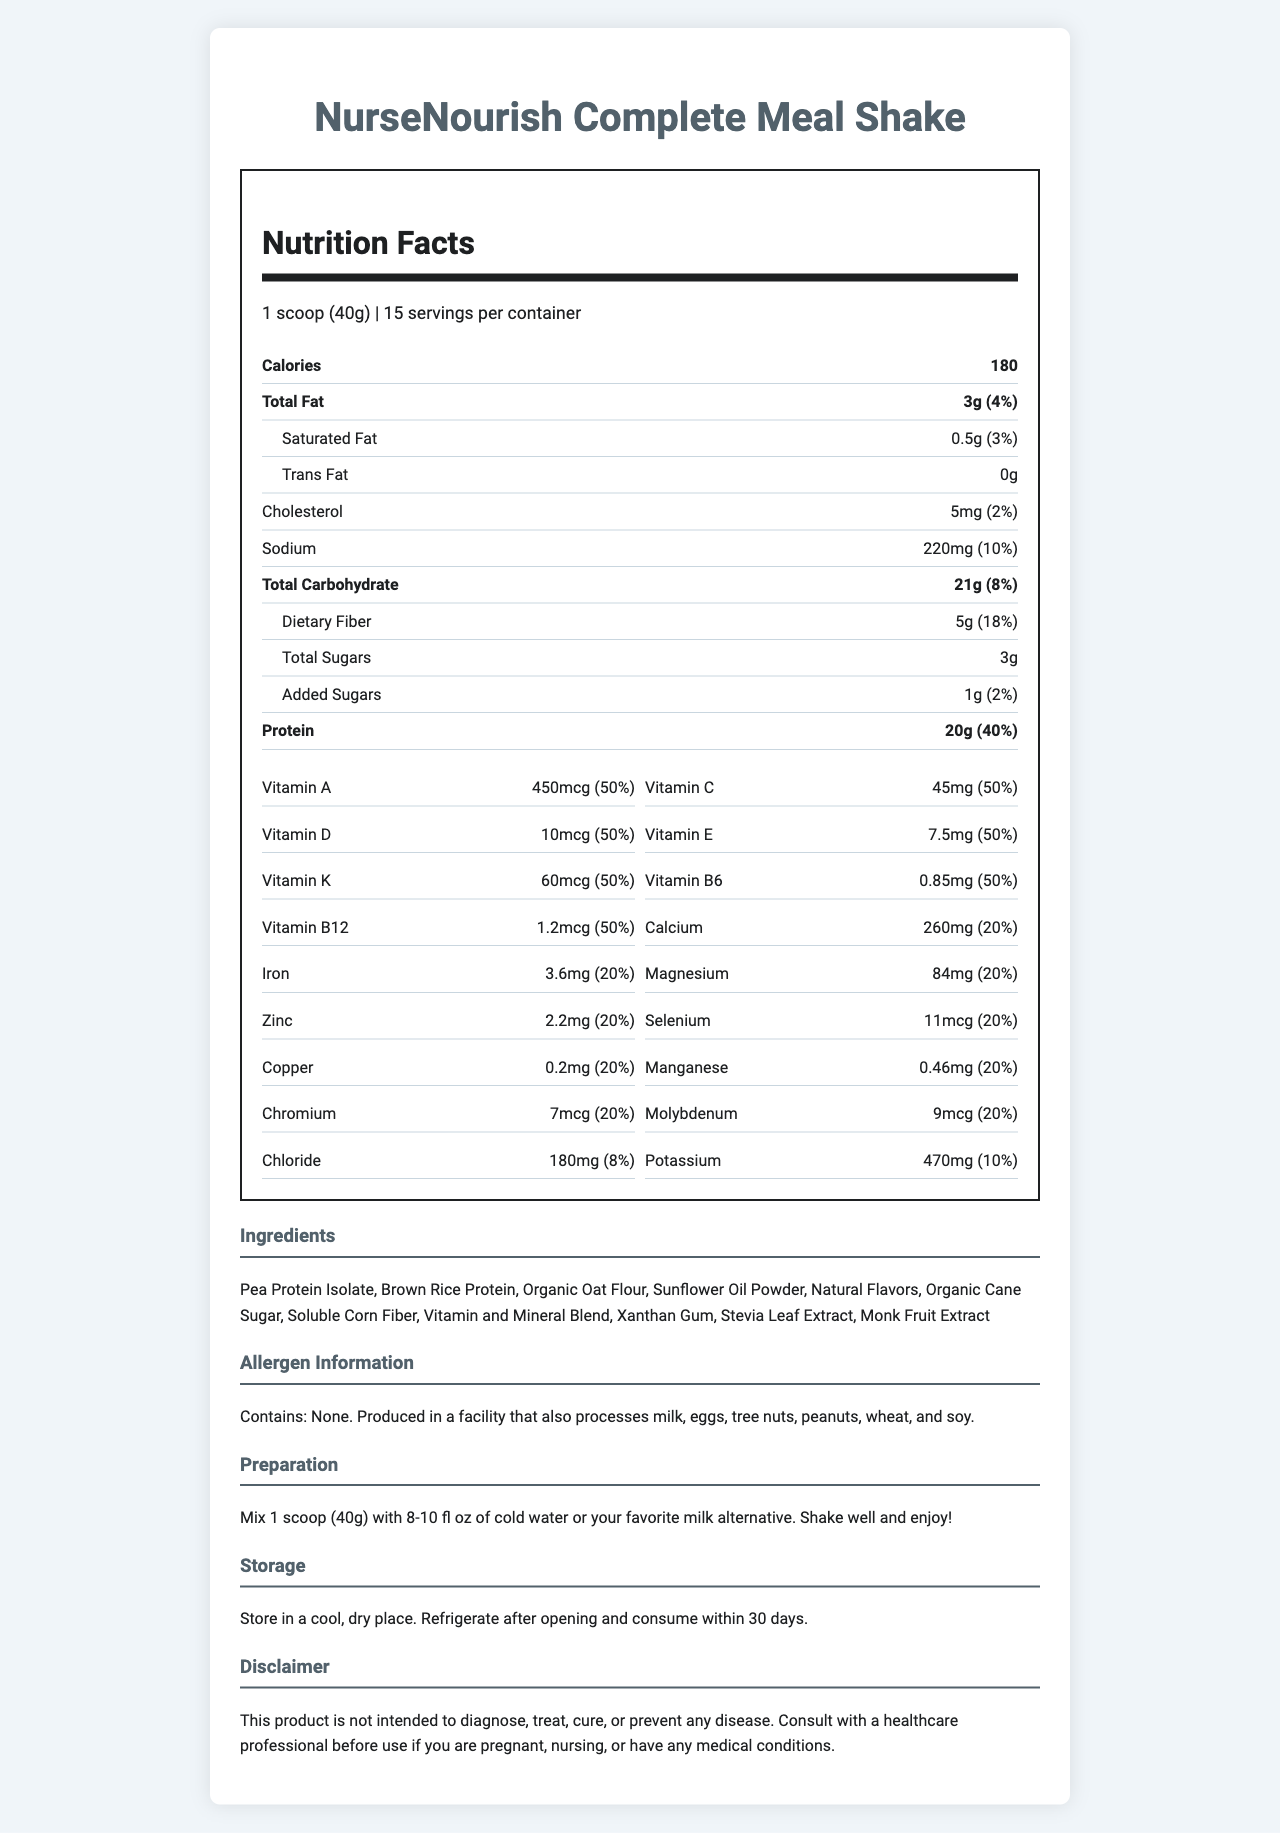what is the serving size for NurseNourish Complete Meal Shake? According to the Nutrition Facts Label, the serving size is listed as 1 scoop (40g).
Answer: 1 scoop (40g) how many servings are there per container? The Nutrition Facts Label indicates that there are 15 servings per container.
Answer: 15 how many calories are in one serving of NurseNourish Complete Meal Shake? The label shows that each serving contains 180 calories.
Answer: 180 what are the total fat and its daily value percentage in one serving? The nutrition label specifies that one serving contains 3 grams of total fat, which is 4% of the daily value.
Answer: 3g (4%) how much protein is in one serving of the meal shake? The label indicates that there are 20 grams of protein per serving.
Answer: 20g what vitamins provide 50% of the daily value per serving of this product? Each of these vitamins contributes to 50% of the daily value per serving as listed on the nutrition label.
Answer: Vitamin A, Vitamin C, Vitamin D, Vitamin E, Vitamin K, Thiamin, Riboflavin, Niacin, Vitamin B6, Folate, Vitamin B12, Biotin, Pantothenic Acid how should you prepare the NurseNourish Complete Meal Shake? The preparation instructions indicate mixing 1 scoop with 8-10 fl oz of cold water or milk alternative, shaking it well before enjoying.
Answer: Mix 1 scoop (40g) with 8-10 fl oz of cold water or your favorite milk alternative. Shake well and enjoy! which of the following is an ingredient in the NurseNourish Complete Meal Shake? A. Palm Oil B. Pea Protein Isolate C. Artificial Flavors D. Soy Protein The ingredients list includes Pea Protein Isolate, while the other options provided are not listed as ingredients.
Answer: B. Pea Protein Isolate what is the allergen information provided for this product? The allergen information notes that the product contains no allergens but is produced in a facility that also processes various allergens like milk, eggs, and nuts.
Answer: Contains: None. Produced in a facility that also processes milk, eggs, tree nuts, peanuts, wheat, and soy. which of the following vitamins is NOT included in the NurseNourish Complete Meal Shake? I. Vitamin B9 II. Vitamin D III. Vitamin A IV. Vitamin B3 Vitamin B9 is not listed on the label; the other vitamins (D, A, B3) are included.
Answer: I. Vitamin B9 is the amount of sodium in one serving less than 250mg? The label states that one serving contains 220mg of sodium, which is less than 250mg.
Answer: Yes briefly summarize the NurseNourish Complete Meal Shake's Nutrition Facts Label. The summary gives an overview of the various sections of the Nutrition Facts Label, highlighting the key nutritional components and additional product information.
Answer: The document provides the nutrition facts for NurseNourish Complete Meal Shake, detailing the serving size (1 scoop, 40g), contained calories (180), macronutrients (fats, carbohydrates, and proteins), and micronutrients (various vitamins and minerals). It includes preparation, storage instructions, ingredients, allergen information, and a disclaimer. This shake is designed to provide quality nutritional support. how many carbohydrates are there in a 120g serving? The document provides nutritional information for a 40g serving, but does not clarify if the amounts scale linearly or provide details for different serving sizes. The answer requires additional data not on the label.
Answer: Not enough information 